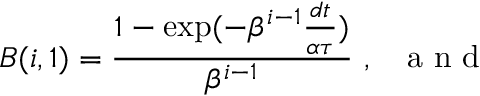<formula> <loc_0><loc_0><loc_500><loc_500>B ( i , 1 ) = \frac { 1 - \exp ( - \beta ^ { i - 1 } \frac { d t } { \alpha \tau } ) } { \beta ^ { i - 1 } } \ , a n d</formula> 